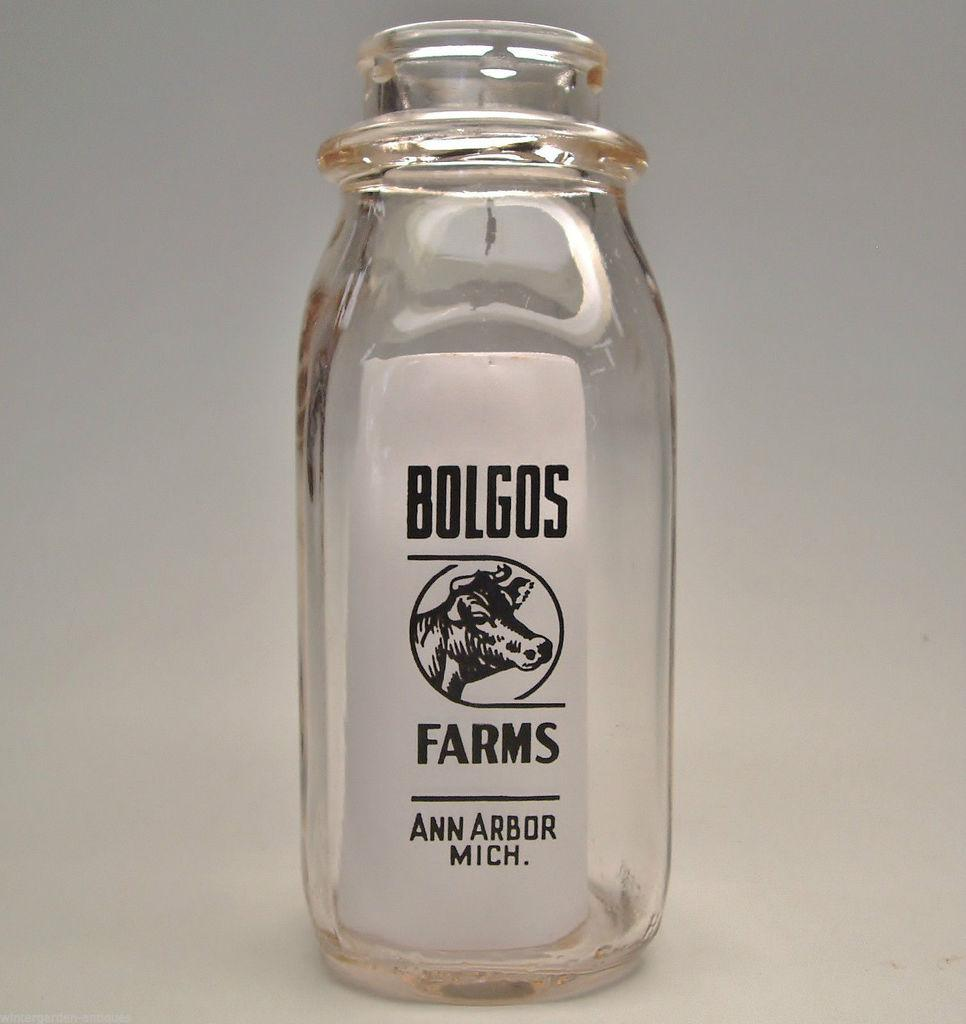<image>
Render a clear and concise summary of the photo. Empty jar with a white label for Bolgos Farms showing a cow. 